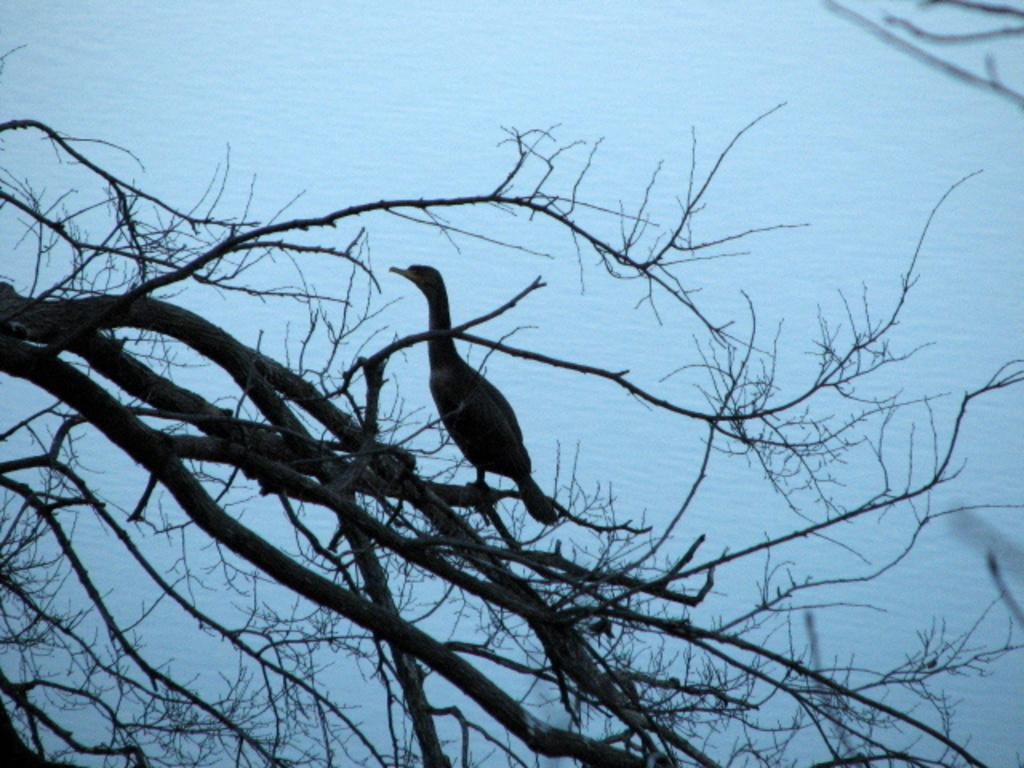What is the main subject in the middle of the image? There is a bird in the middle of the image. What type of vegetation is present at the bottom of the image? There are trees at the bottom of the image. What can be seen in the background of the image? There is water visible in the background of the image. What type of cast can be seen on the bird's wing in the image? There is no cast visible on the bird's wing in the image. How does the bird provide comfort to the trees in the image? The bird does not provide comfort to the trees in the image; it is simply perched among them. 